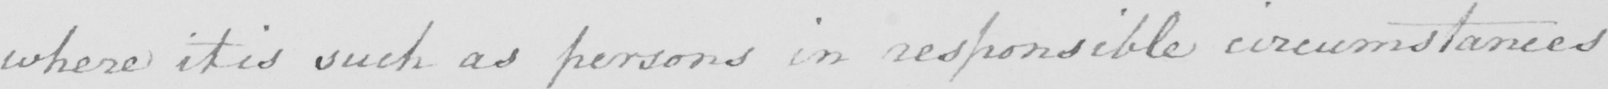Transcribe the text shown in this historical manuscript line. where it is such as persons in responsible circumstances 